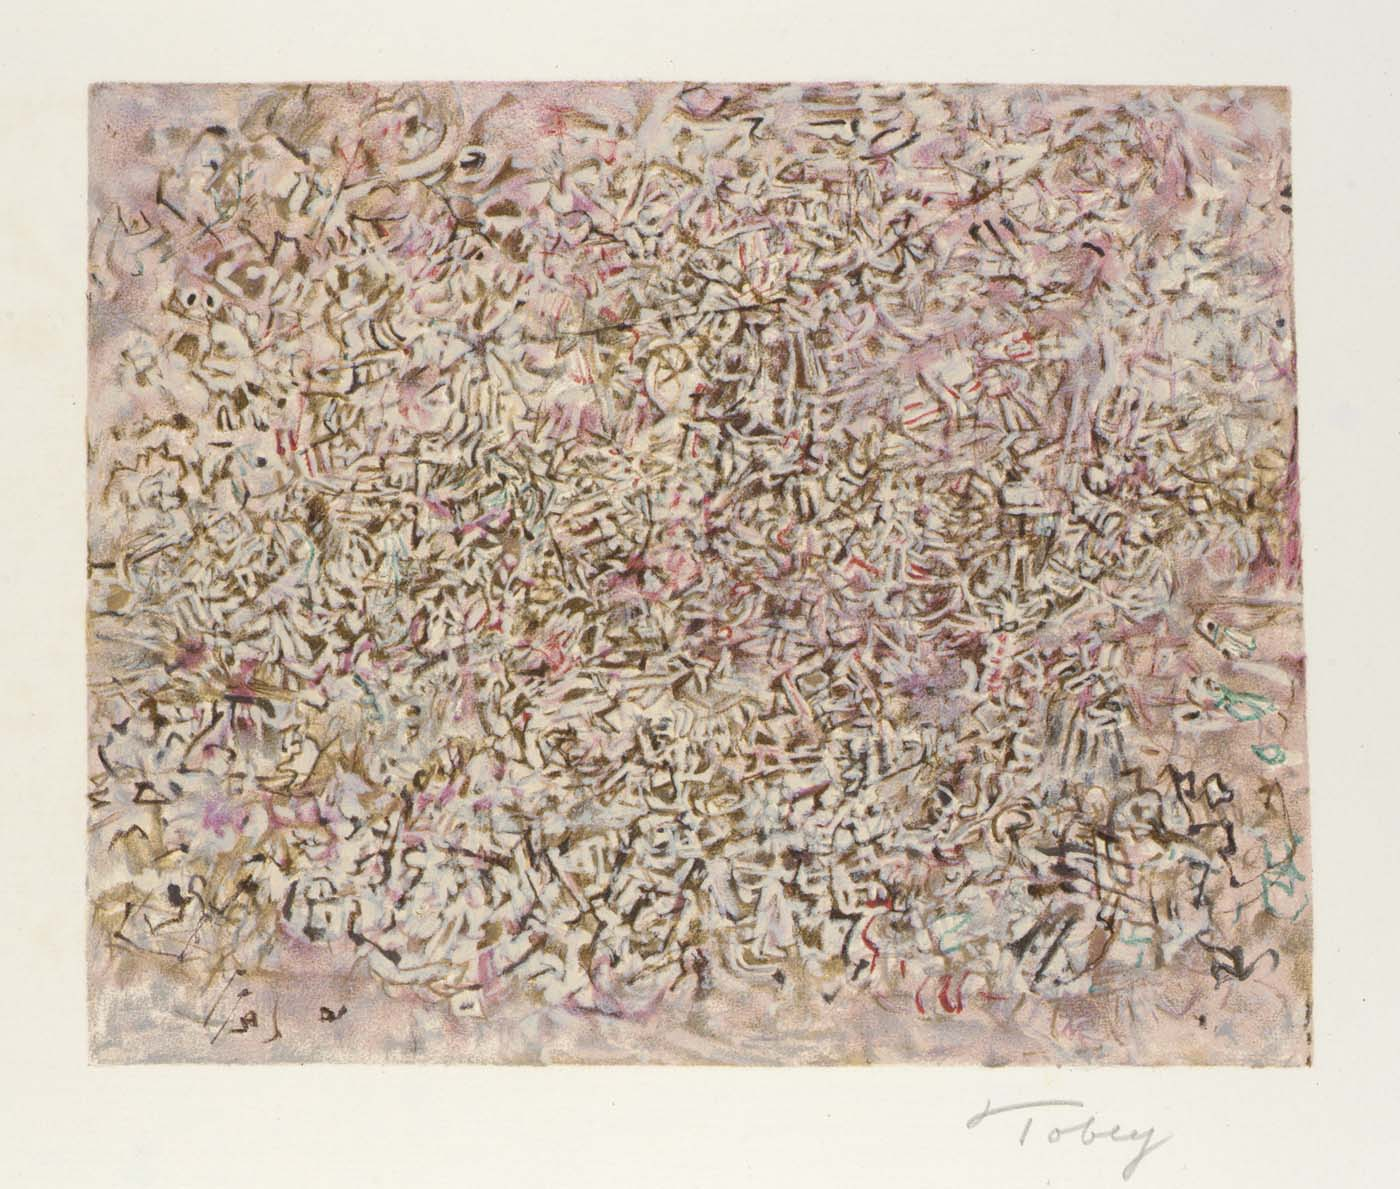What might be the inspiration behind this abstract artwork? This type of abstract expressionism could be inspired by a variety of sources, ranging from the artist's emotional or psychological state to their reflections on society. The chaotic and densely layered style might represent the complexity of human emotions or the tumultuous nature of modern life. It's also possible that the artist was experimenting with forms and colors to evoke a sense of depth and movement, pushing the boundaries of traditional visual representation. 